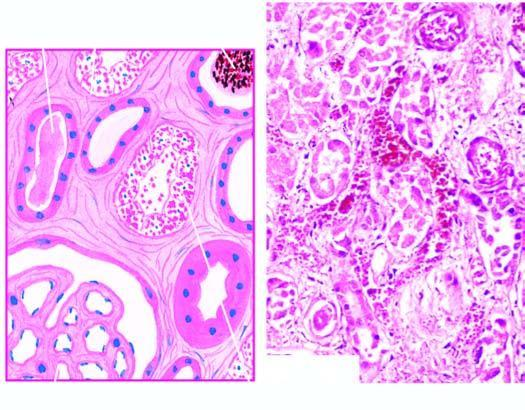re the affected regions lined by regenerating thin and flat epithelium?
Answer the question using a single word or phrase. Yes 